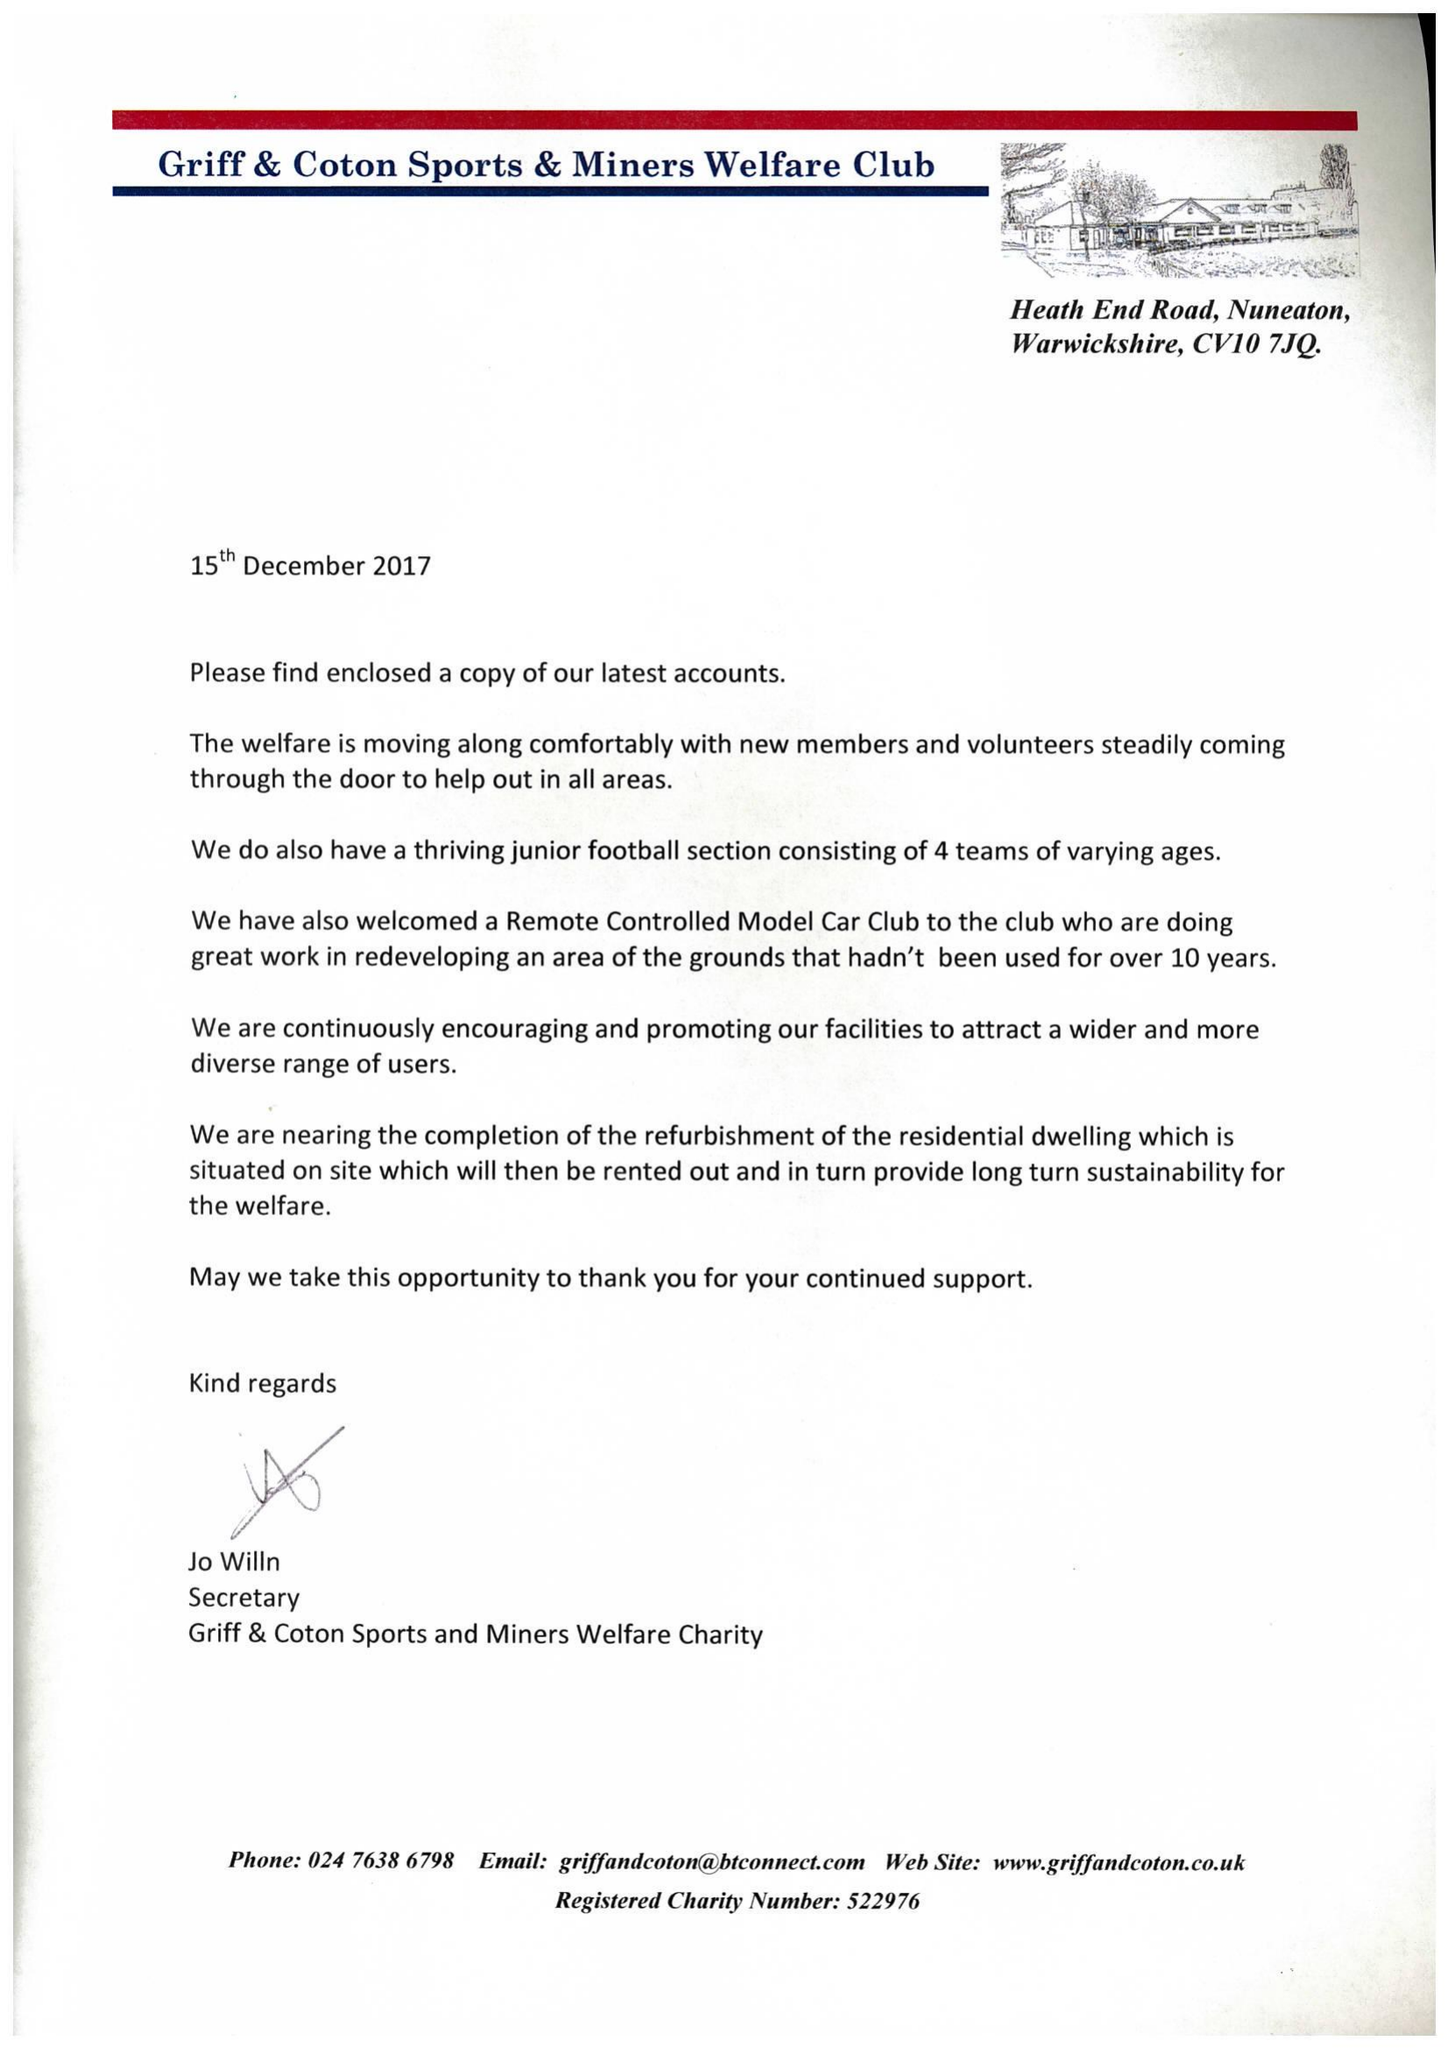What is the value for the spending_annually_in_british_pounds?
Answer the question using a single word or phrase. 234376.00 